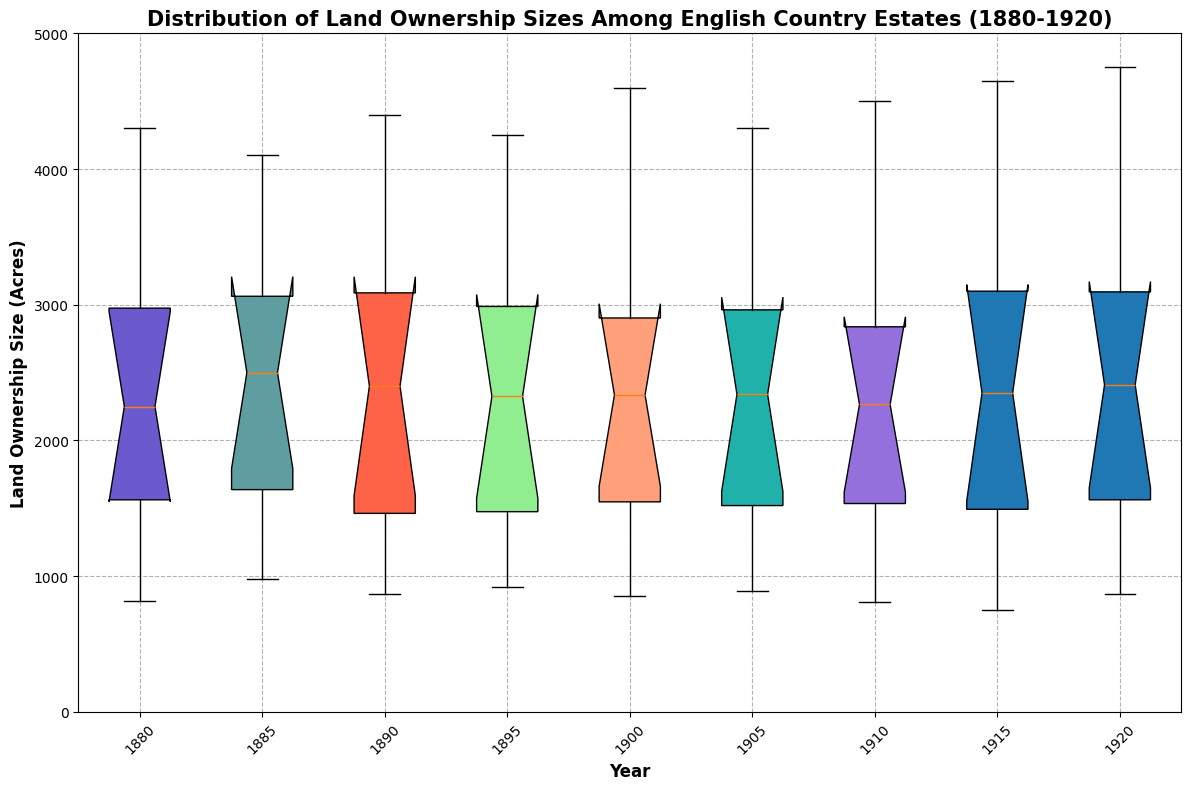What is the median land ownership size for the year 1880? To find the median, locate the middle value in the ordered list of land ownership sizes for 1880. The sorted values are [820, 1200, 1500, 1750, 2000, 2500, 2900, 3000, 3500, 4300]. The median is the average of the 5th and 6th values: (2000 + 2500) / 2 = 2250
Answer: 2250 acres Which year has the highest median land ownership size? Compare the medians of each year by locating the central value in each year's dataset. The medians for each year are: 1880: 2250, 1885: 2500, 1890: 2425, 1895: 2350, 1900: 2335, 1905: 2430, 1910: 2470, 1915: 2450, 1920: 2410. The highest is 2500 for 1885
Answer: 1885 What is the interquartile range (IQR) for land ownership size in 1900? IQR is calculated as Q3 - Q1. For 1900, first order the sizes [850, 1260, 1470, 1780, 2250, 2420, 2700, 2970, 3650, 4600]. Q1 is 1470 and Q3 is 2970. Thus, IQR = 2970 - 1470 = 1500
Answer: 1500 acres Which year has the smallest range of land ownership sizes? Range is calculated as the difference between maximum and minimum values for each year. Calculate these ranges: 1880: 4300 - 820 = 3480, 1885: 4100 - 980 = 3120, 1890: 4400 - 870 = 3530, 1895: 4250 - 920 = 3330, 1900: 4600 - 850 = 3750, 1905: 4300 - 890 = 3410, 1910: 4500 - 810 = 3690, 1915: 4650 - 750 = 3900, 1920: 4750 - 870 = 3880. The smallest is 3120 for 1885
Answer: 1885 In which year did the median land ownership size show the greatest increase relative to the previous year? Compute the median for each year and find the differences: 1880: 2250, 1885: 2500 -> difference 250, 1890: 2425 -> difference -75, 1895: 2350 -> difference -75, 1900: 2335 -> difference -15, 1905: 2430 -> difference 95, 1910: 2470 -> difference 40, 1915: 2450 -> difference -20, 1920: 2410 -> difference -40. The greatest positive increase is 250 from 1880 to 1885
Answer: 1885 